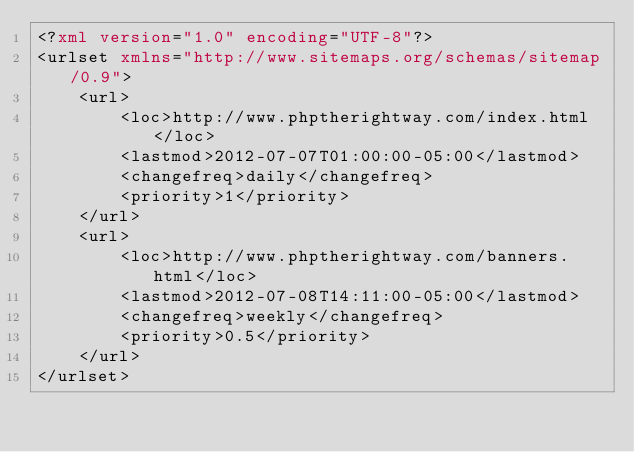Convert code to text. <code><loc_0><loc_0><loc_500><loc_500><_XML_><?xml version="1.0" encoding="UTF-8"?>
<urlset xmlns="http://www.sitemaps.org/schemas/sitemap/0.9">
    <url>
        <loc>http://www.phptherightway.com/index.html</loc>
        <lastmod>2012-07-07T01:00:00-05:00</lastmod>
        <changefreq>daily</changefreq>
        <priority>1</priority>
    </url>
    <url>
        <loc>http://www.phptherightway.com/banners.html</loc>
        <lastmod>2012-07-08T14:11:00-05:00</lastmod>
        <changefreq>weekly</changefreq>
        <priority>0.5</priority>
    </url>
</urlset>
</code> 